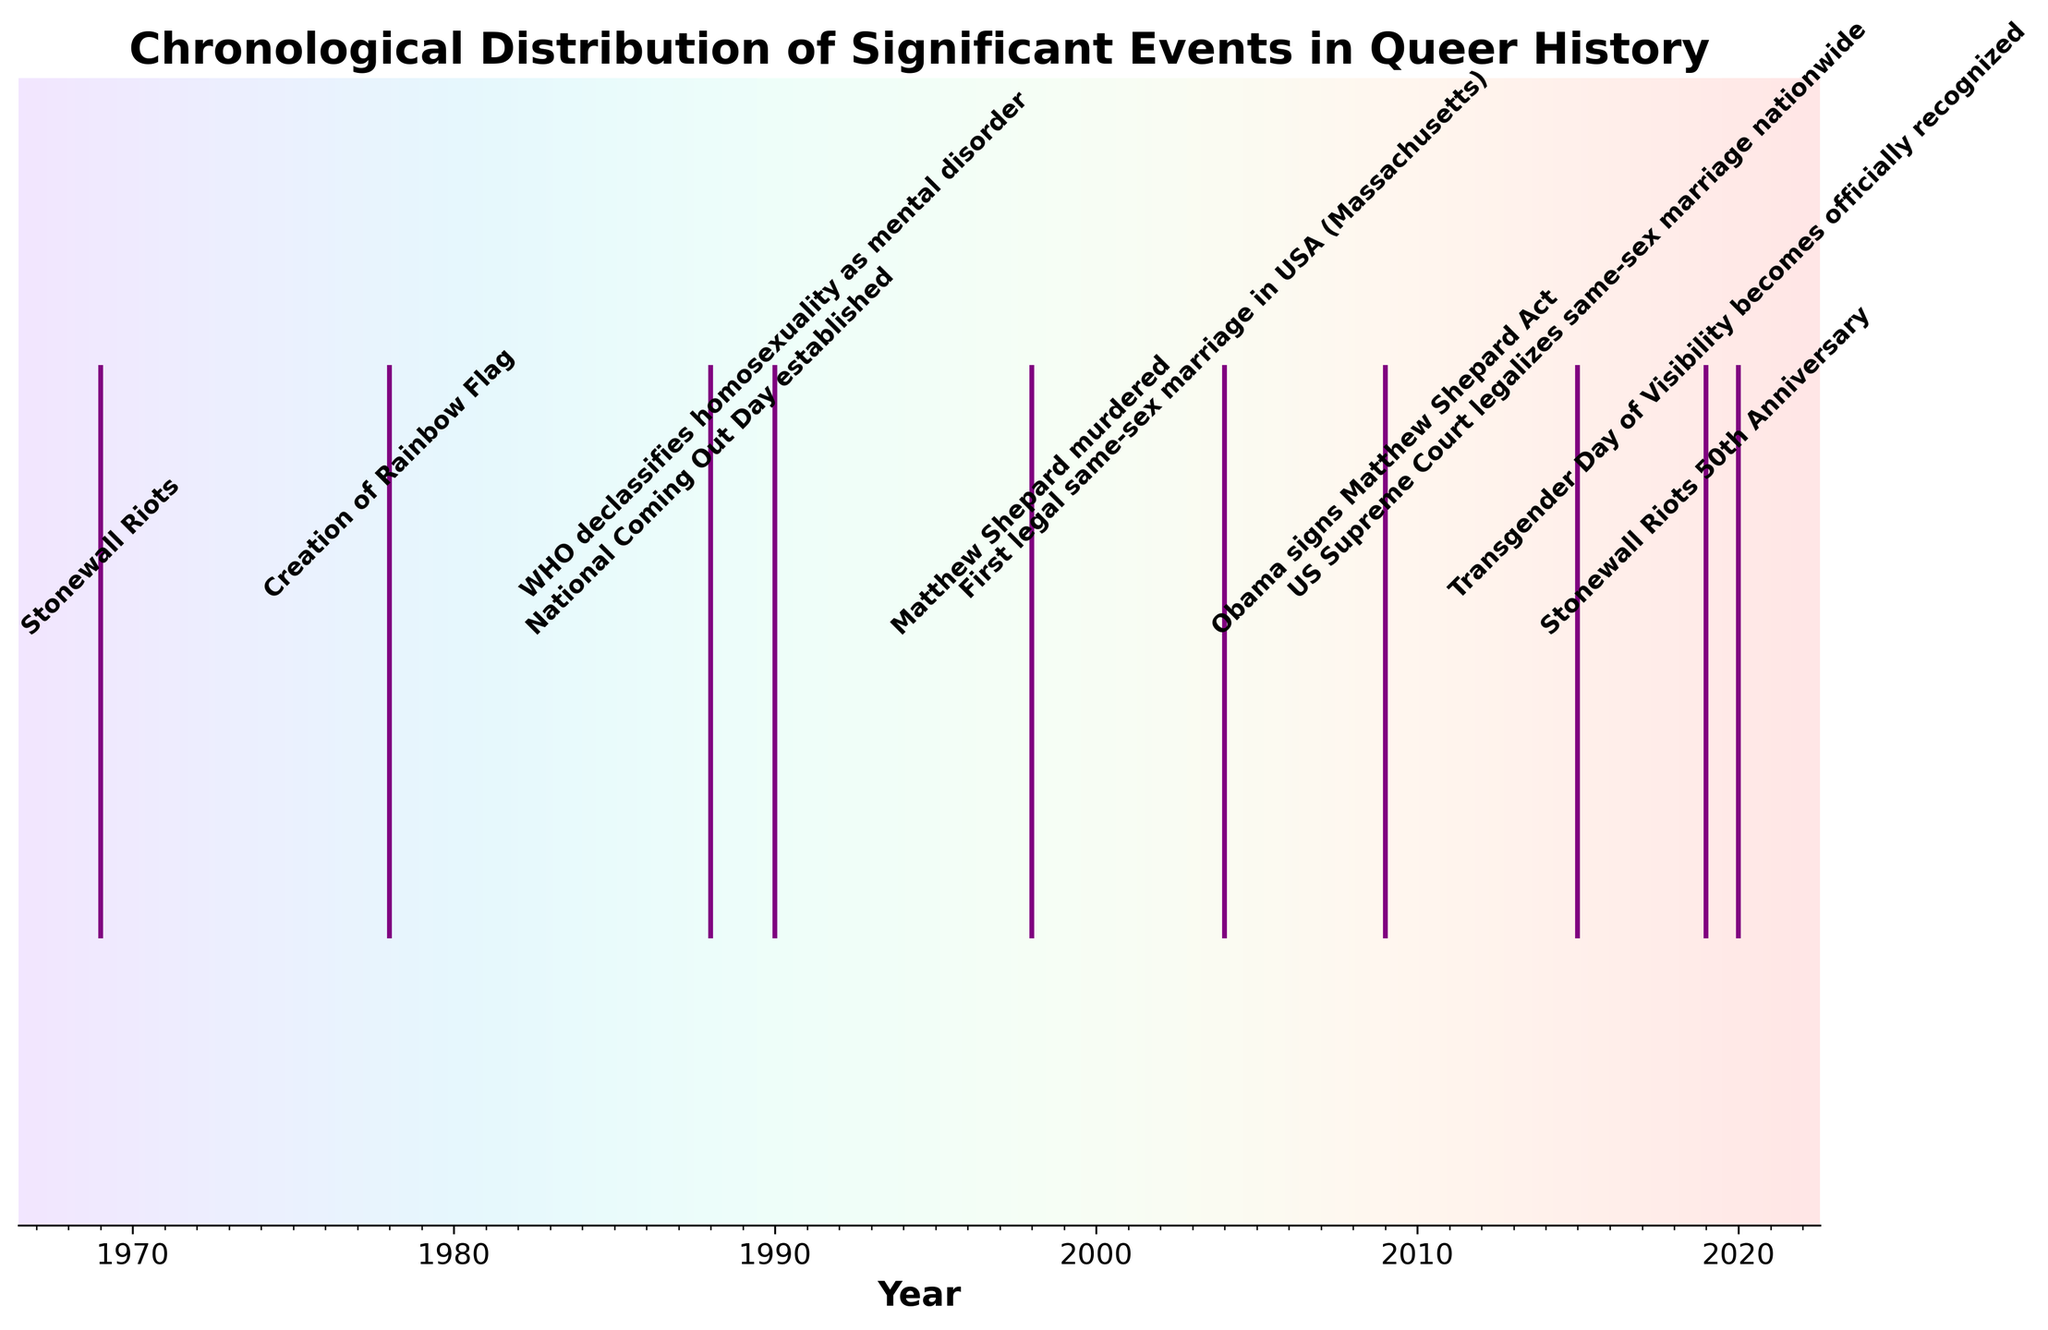What is the title of the figure? The figure's title is usually located at the top of the plot and summarizes its content. In this case, the title is visible as 'Chronological Distribution of Significant Events in Queer History'.
Answer: Chronological Distribution of Significant Events in Queer History How many significant events are depicted in the figure? By counting the number of labels or markers in the figure, we can ascertain the total number of events. Each event is represented by an annotation and a purple line.
Answer: 10 Which event is commemorated on June 26? By looking for the event label associated with this specific date, we find 'US Supreme Court legalizes same-sex marriage nationwide'.
Answer: US Supreme Court legalizes same-sex marriage nationwide How many events occurred in October? By inspecting the event labels and their annotated dates, there are several events in October: 'National Coming Out Day established', 'Matthew Shepard murdered', and 'Obama signs Matthew Shepard Act'.
Answer: 3 What is the approximate time span covered by the events on the plot? Observing the x-axis labels, the earliest event is in 1969 and the latest in 2020. Subtracting these years shows the plot spans about 51 years.
Answer: 51 years Which event occurred in both 1990 and 2004 on the same date? Checking the events for these particular years, we see that both 'WHO declassifies homosexuality as mental disorder' and 'First legal same-sex marriage in USA (Massachusetts)' share the date May 17.
Answer: WHO declassifies homosexuality as mental disorder and First legal same-sex marriage in USA (Massachusetts) Is there any event whose 50th anniversary is marked on this plot? Identifying anniversaries involves looking for events denoted as such. The 'Stonewall Riots 50th Anniversary' in 2019 commemorates the 1969 Stonewall Riots.
Answer: Stonewall Riots 50th Anniversary Which month has the highest count of significant event commemorations? By examining the labels, June has multiple events: 'Stonewall Riots', 'Creation of Rainbow Flag', 'US Supreme Court legalizes same-sex marriage nationwide', 'Stonewall Riots 50th Anniversary'. This makes it the month with the highest number.
Answer: June Which event occurred closest to the end of the time span? Referring to the last annotated date on the x-axis, 'Transgender Day of Visibility becomes officially recognized' is in 2020, which is the latest event shown.
Answer: Transgender Day of Visibility becomes officially recognized What is the chronological difference between the establishment of National Coming Out Day and the murder of Matthew Shepard? National Coming Out Day was established in 1988 and Matthew Shepard was murdered in 1998. Subtracting these years: 1998 - 1988 = 10 years.
Answer: 10 years 